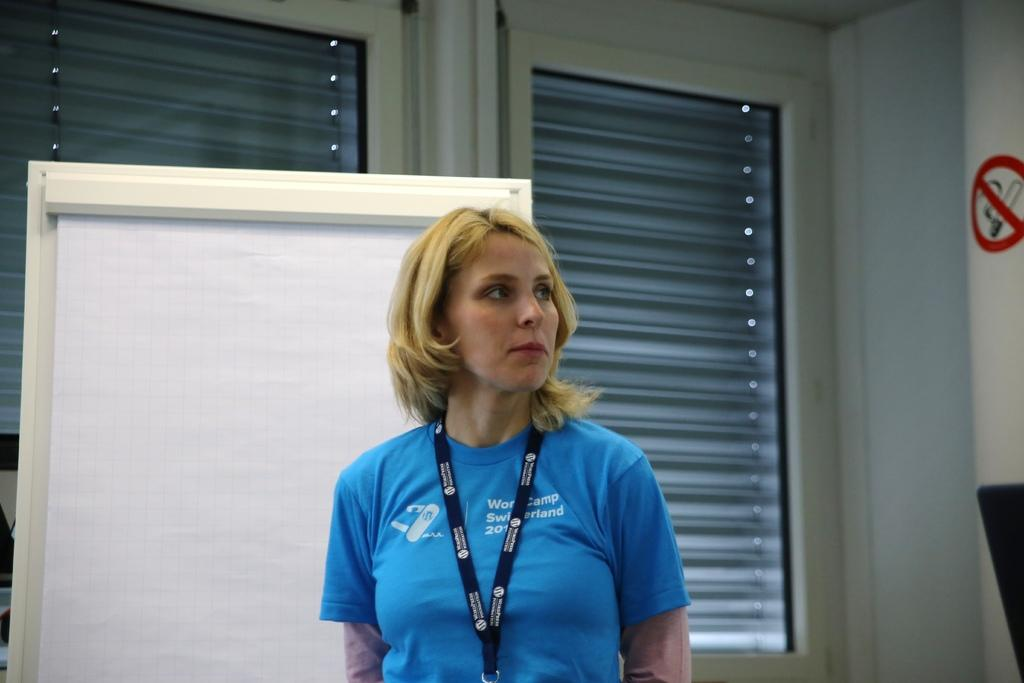Who is the main subject in the image? There is a woman in the middle of the image. What is the woman wearing? The woman is wearing a t-shirt. What can be seen on the left side of the image? There is a board on the left side of the image. What is visible in the background of the image? There are windows visible in the background of the image. What type of skate is the woman using in the image? There is no skate present in the image; the woman is standing on the ground. What drink is the woman holding in the image? There is no drink visible in the image; the woman is not holding anything. 